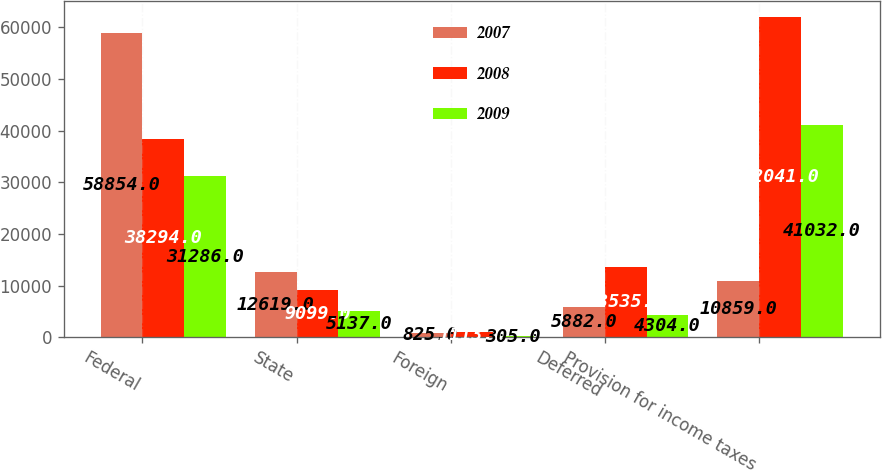Convert chart. <chart><loc_0><loc_0><loc_500><loc_500><stacked_bar_chart><ecel><fcel>Federal<fcel>State<fcel>Foreign<fcel>Deferred<fcel>Provision for income taxes<nl><fcel>2007<fcel>58854<fcel>12619<fcel>825<fcel>5882<fcel>10859<nl><fcel>2008<fcel>38294<fcel>9099<fcel>1113<fcel>13535<fcel>62041<nl><fcel>2009<fcel>31286<fcel>5137<fcel>305<fcel>4304<fcel>41032<nl></chart> 